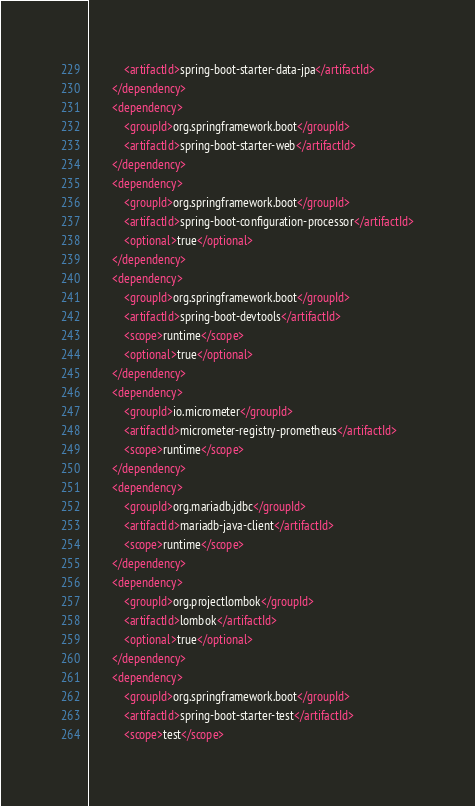<code> <loc_0><loc_0><loc_500><loc_500><_XML_>            <artifactId>spring-boot-starter-data-jpa</artifactId>
        </dependency>
        <dependency>
            <groupId>org.springframework.boot</groupId>
            <artifactId>spring-boot-starter-web</artifactId>
        </dependency>
        <dependency>
            <groupId>org.springframework.boot</groupId>
            <artifactId>spring-boot-configuration-processor</artifactId>
            <optional>true</optional>
        </dependency>
        <dependency>
            <groupId>org.springframework.boot</groupId>
            <artifactId>spring-boot-devtools</artifactId>
            <scope>runtime</scope>
            <optional>true</optional>
        </dependency>
        <dependency>
            <groupId>io.micrometer</groupId>
            <artifactId>micrometer-registry-prometheus</artifactId>
            <scope>runtime</scope>
        </dependency>
        <dependency>
            <groupId>org.mariadb.jdbc</groupId>
            <artifactId>mariadb-java-client</artifactId>
            <scope>runtime</scope>
        </dependency>
        <dependency>
            <groupId>org.projectlombok</groupId>
            <artifactId>lombok</artifactId>
            <optional>true</optional>
        </dependency>
        <dependency>
            <groupId>org.springframework.boot</groupId>
            <artifactId>spring-boot-starter-test</artifactId>
            <scope>test</scope></code> 